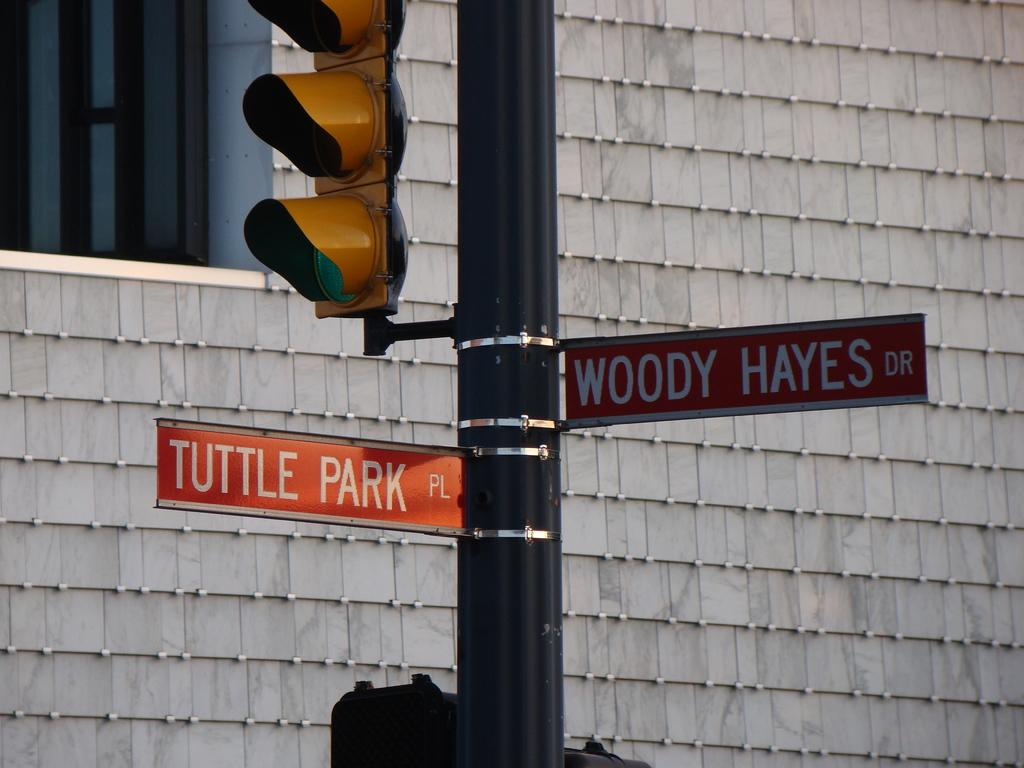<image>
Write a terse but informative summary of the picture. A traffic light has two street signs beneath it that say Tuttle Park Pl and Woody Hayes Dr. 